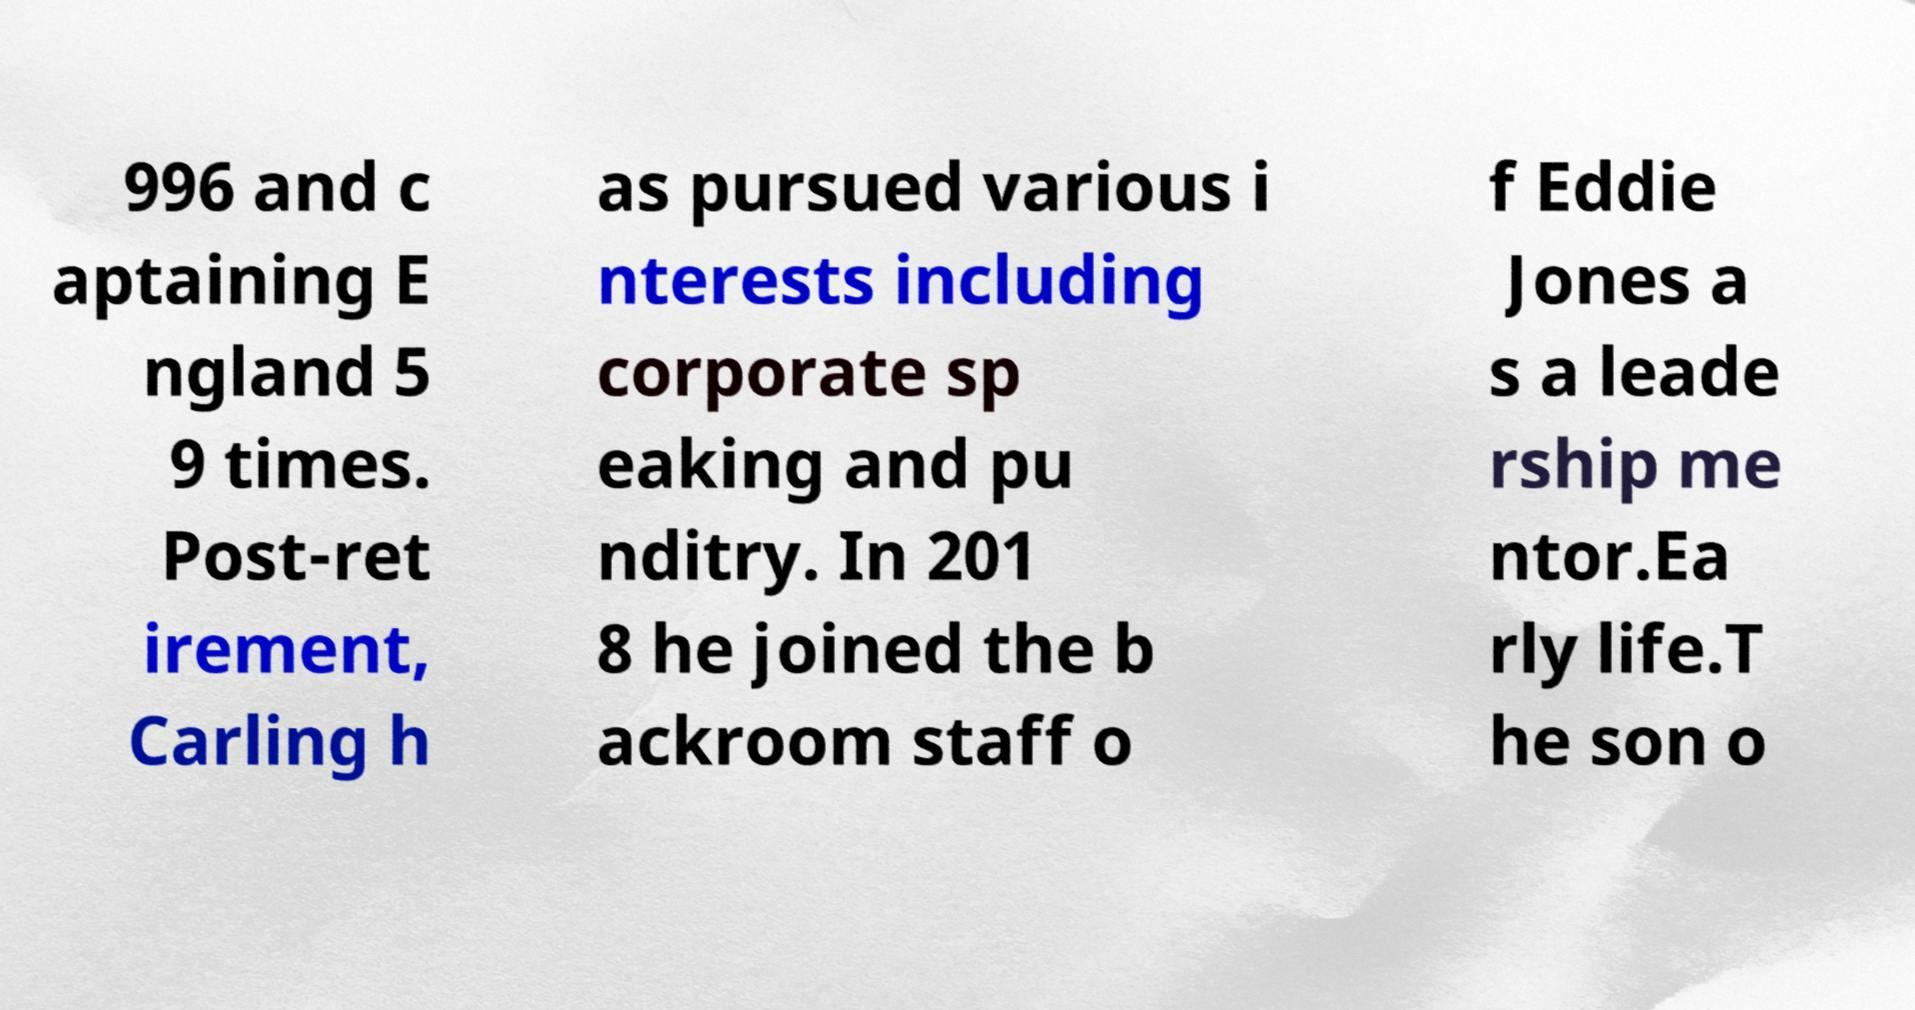Can you accurately transcribe the text from the provided image for me? 996 and c aptaining E ngland 5 9 times. Post-ret irement, Carling h as pursued various i nterests including corporate sp eaking and pu nditry. In 201 8 he joined the b ackroom staff o f Eddie Jones a s a leade rship me ntor.Ea rly life.T he son o 